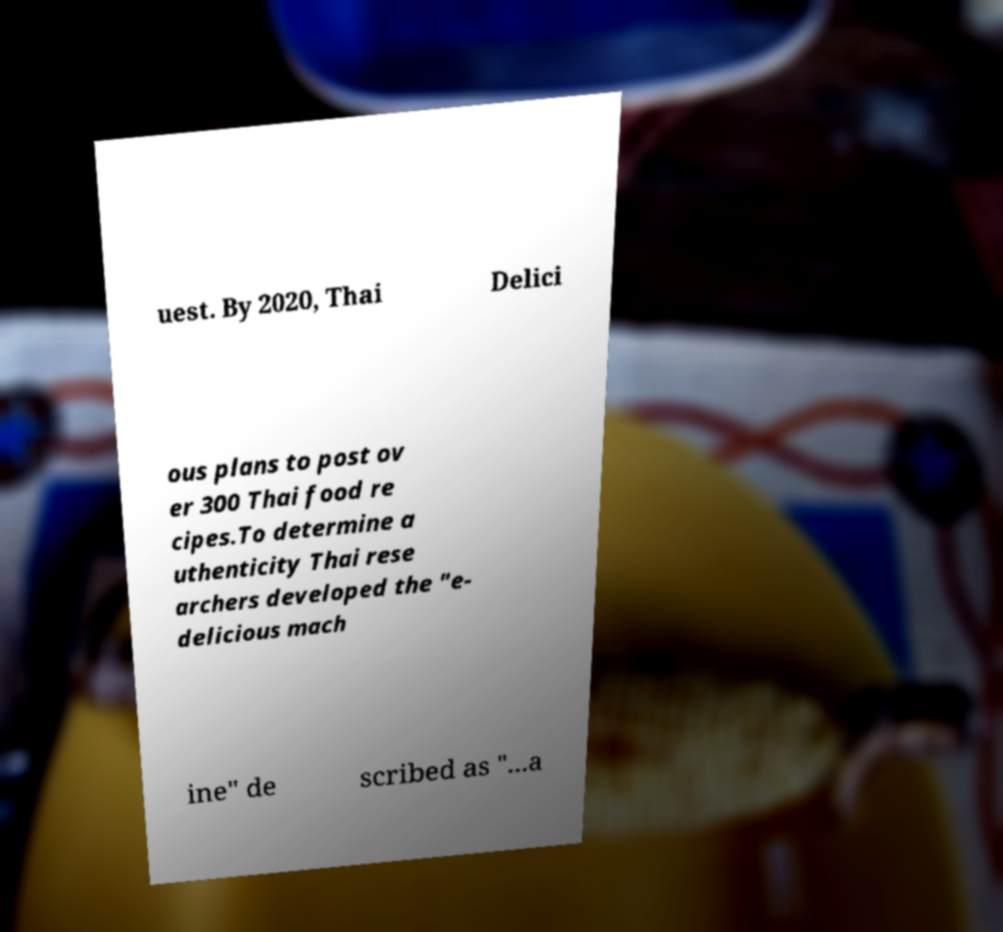Please read and relay the text visible in this image. What does it say? uest. By 2020, Thai Delici ous plans to post ov er 300 Thai food re cipes.To determine a uthenticity Thai rese archers developed the "e- delicious mach ine" de scribed as "...a 